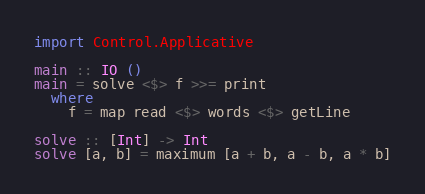<code> <loc_0><loc_0><loc_500><loc_500><_Haskell_>import Control.Applicative

main :: IO ()
main = solve <$> f >>= print
  where
    f = map read <$> words <$> getLine

solve :: [Int] -> Int
solve [a, b] = maximum [a + b, a - b, a * b]
</code> 